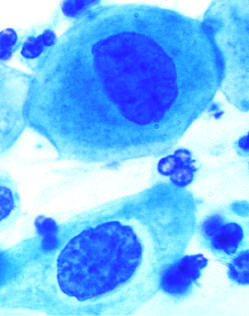does the parenchymal architecture reflect the progressive loss of cellular differentiation on the surface of the cervical lesions from which these cells are exfoliated?
Answer the question using a single word or phrase. No 